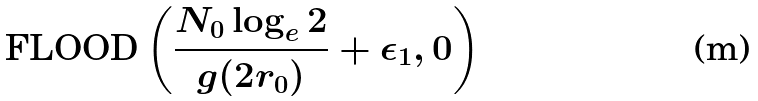Convert formula to latex. <formula><loc_0><loc_0><loc_500><loc_500>\text {FLOOD} \left ( \frac { N _ { 0 } \log _ { e } 2 } { g ( 2 r _ { 0 } ) } + \epsilon _ { 1 } , 0 \right )</formula> 